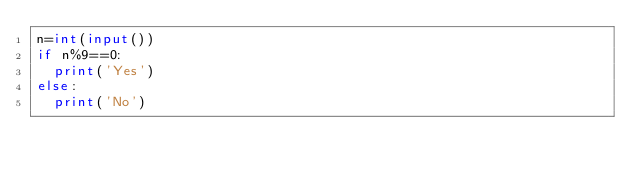<code> <loc_0><loc_0><loc_500><loc_500><_Python_>n=int(input())
if n%9==0:
	print('Yes')
else:
	print('No')
  </code> 